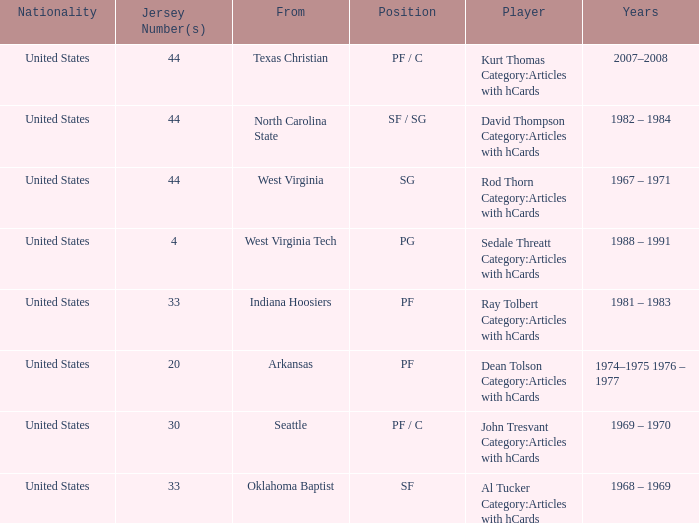What years did the player with the jersey number 33 and played position pf play? 1981 – 1983. 